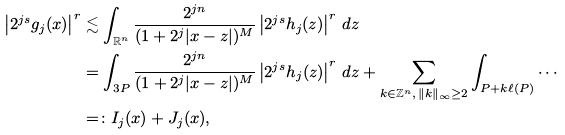Convert formula to latex. <formula><loc_0><loc_0><loc_500><loc_500>\left | 2 ^ { j s } g _ { j } ( x ) \right | ^ { r } & \lesssim \int _ { \mathbb { R } ^ { n } } \frac { 2 ^ { j n } } { ( 1 + 2 ^ { j } | x - z | ) ^ { M } } \left | 2 ^ { j s } h _ { j } ( z ) \right | ^ { r } \, d z \\ & = \int _ { 3 P } \frac { 2 ^ { j n } } { ( 1 + 2 ^ { j } | x - z | ) ^ { M } } \left | 2 ^ { j s } h _ { j } ( z ) \right | ^ { r } \, d z + \sum _ { k \in \mathbb { Z } ^ { n } , \, \| k \| _ { \infty } \geq 2 } \int _ { P + k \ell ( P ) } \cdots \\ & = \colon I _ { j } ( x ) + J _ { j } ( x ) ,</formula> 